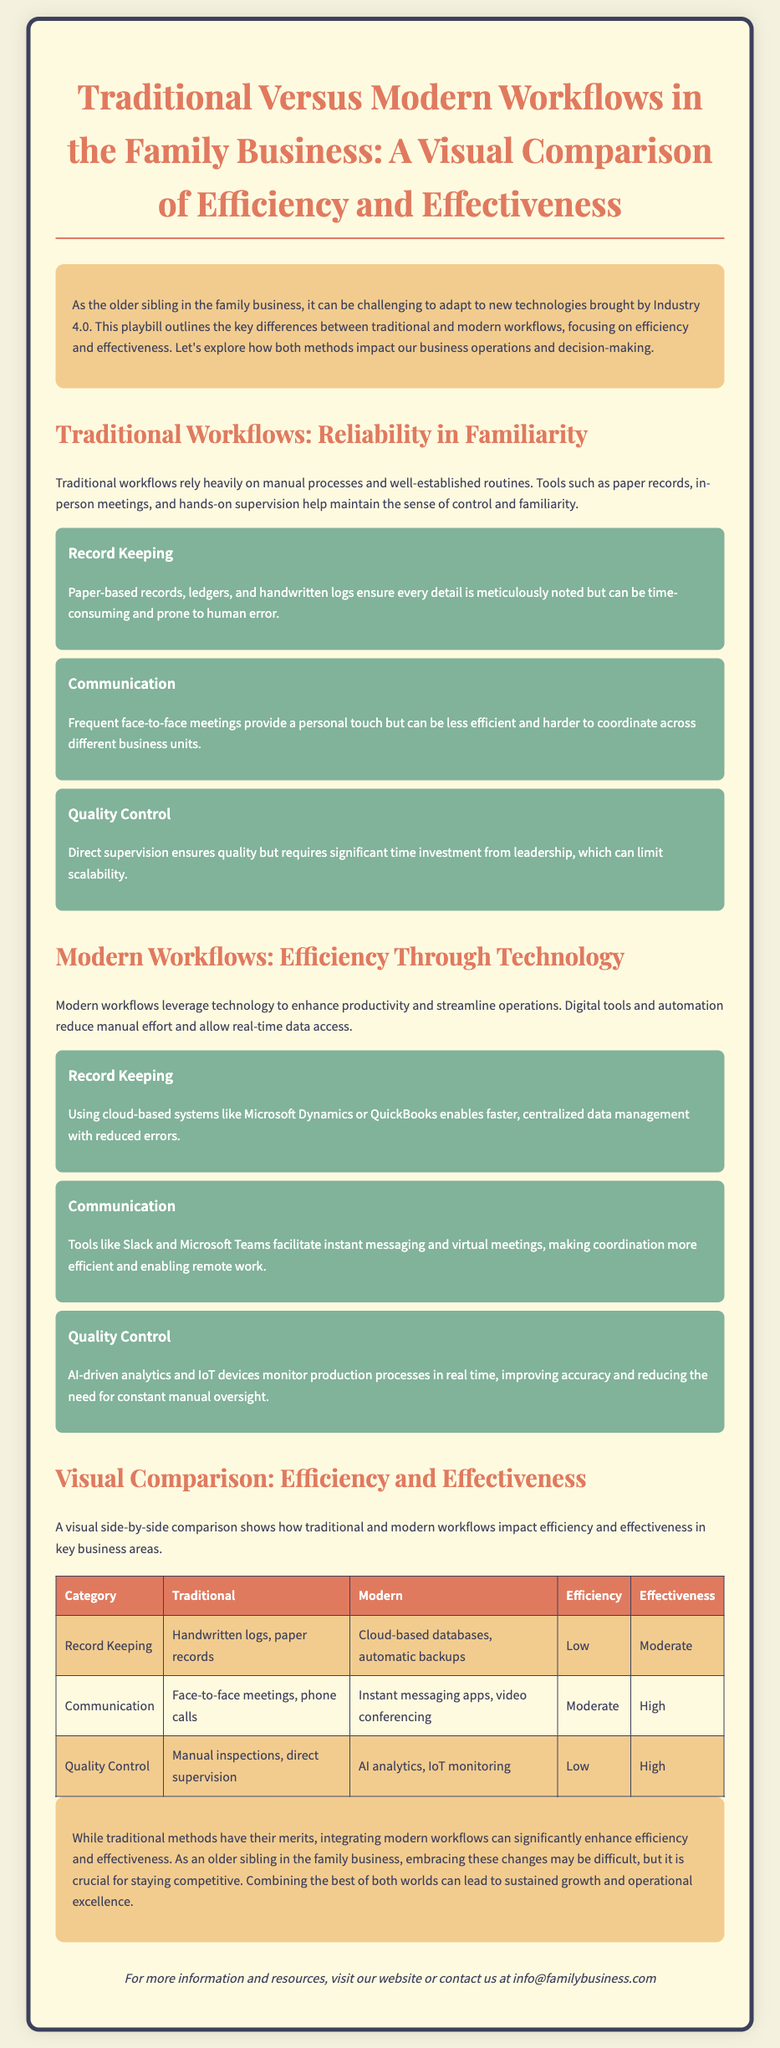What is the title of the document? The title of the document is stated at the beginning in a large font, which is "Traditional Versus Modern Workflows in the Family Business: A Visual Comparison of Efficiency and Effectiveness."
Answer: Traditional Versus Modern Workflows in the Family Business: A Visual Comparison of Efficiency and Effectiveness What is the primary focus of the playbill? The introduction of the playbill describes that it focuses on key differences between traditional and modern workflows, particularly regarding efficiency and effectiveness.
Answer: Efficiency and effectiveness What is a tool mentioned for traditional record keeping? The document describes that traditional workflows utilize paper-based records, ledgers, and handwritten logs for record keeping.
Answer: Paper-based records What communication method is highlighted for modern workflows? The document mentions that modern workflows use tools like Slack and Microsoft Teams for communication to facilitate instant messaging.
Answer: Slack and Microsoft Teams How does traditional quality control ensure standards? The playbill states that traditional quality control relies on direct supervision to ensure quality.
Answer: Direct supervision Which workflow has a higher effectiveness rating for communication? The visual comparison table reveals that modern workflows have a higher effectiveness rating compared to traditional workflows in communication.
Answer: Modern What category has the lowest efficiency according to the document? The table shows that traditional record keeping has the lowest efficiency rating.
Answer: Record Keeping What does the conclusion suggest about combining workflows? The conclusion emphasizes that combining the best of both traditional and modern workflows can lead to sustained growth and operational excellence.
Answer: Combined workflows What is the background color of the playbill? The CSS code and the body style define the background color of the playbill as a light beige color represented by the hex code #fefae0.
Answer: #fefae0 